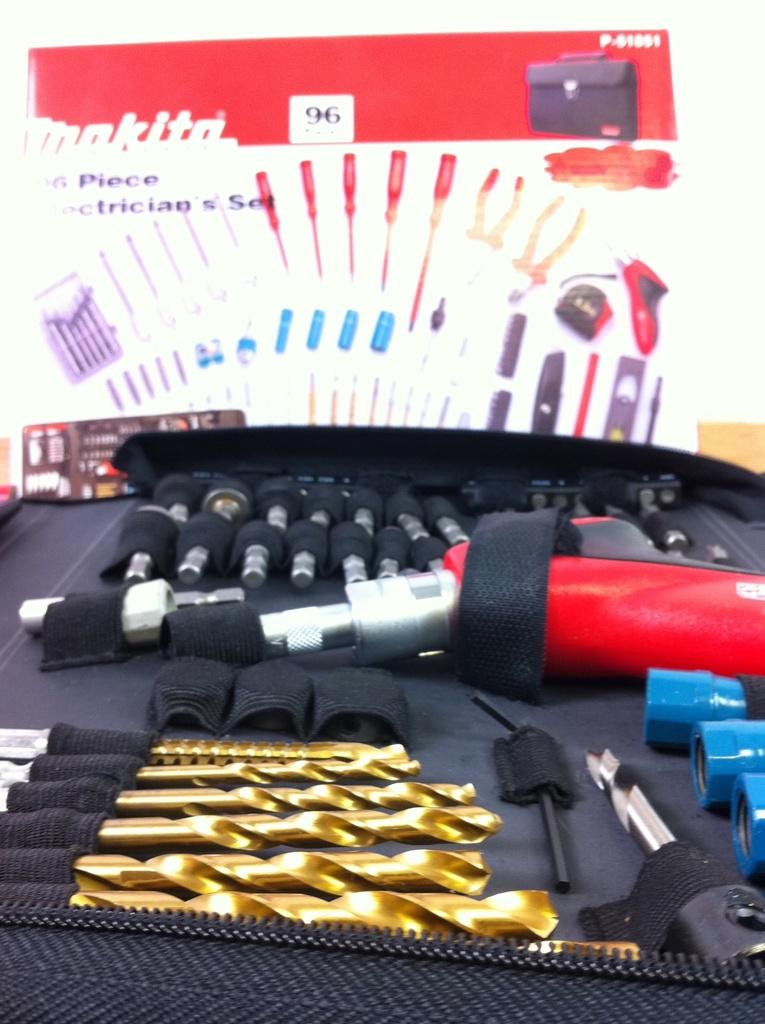What is the main subject of the image? The main subject of the image is a drilling kit. Is the drilling kit in its original packaging? Yes, the drilling kit is in its carton. Where is the carton located in the image? The carton is in the background of the image. What type of creature is interacting with the drilling kit in the image? There is no creature present in the image; it only features the drilling kit in its carton. Can you describe the stranger in the image? There is no stranger present in the image; it only features the drilling kit in its carton. 